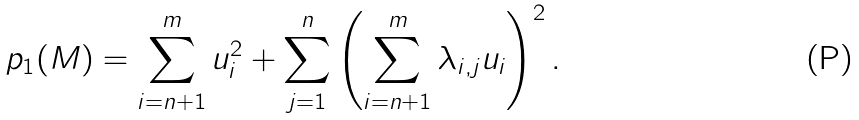Convert formula to latex. <formula><loc_0><loc_0><loc_500><loc_500>p _ { 1 } ( M ) = \sum _ { i = n + 1 } ^ { m } u _ { i } ^ { 2 } + \sum _ { j = 1 } ^ { n } \left ( \sum _ { i = n + 1 } ^ { m } \lambda _ { i , j } u _ { i } \right ) ^ { 2 } .</formula> 